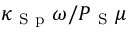Convert formula to latex. <formula><loc_0><loc_0><loc_500><loc_500>\kappa _ { S p } \omega / P _ { S } \mu</formula> 